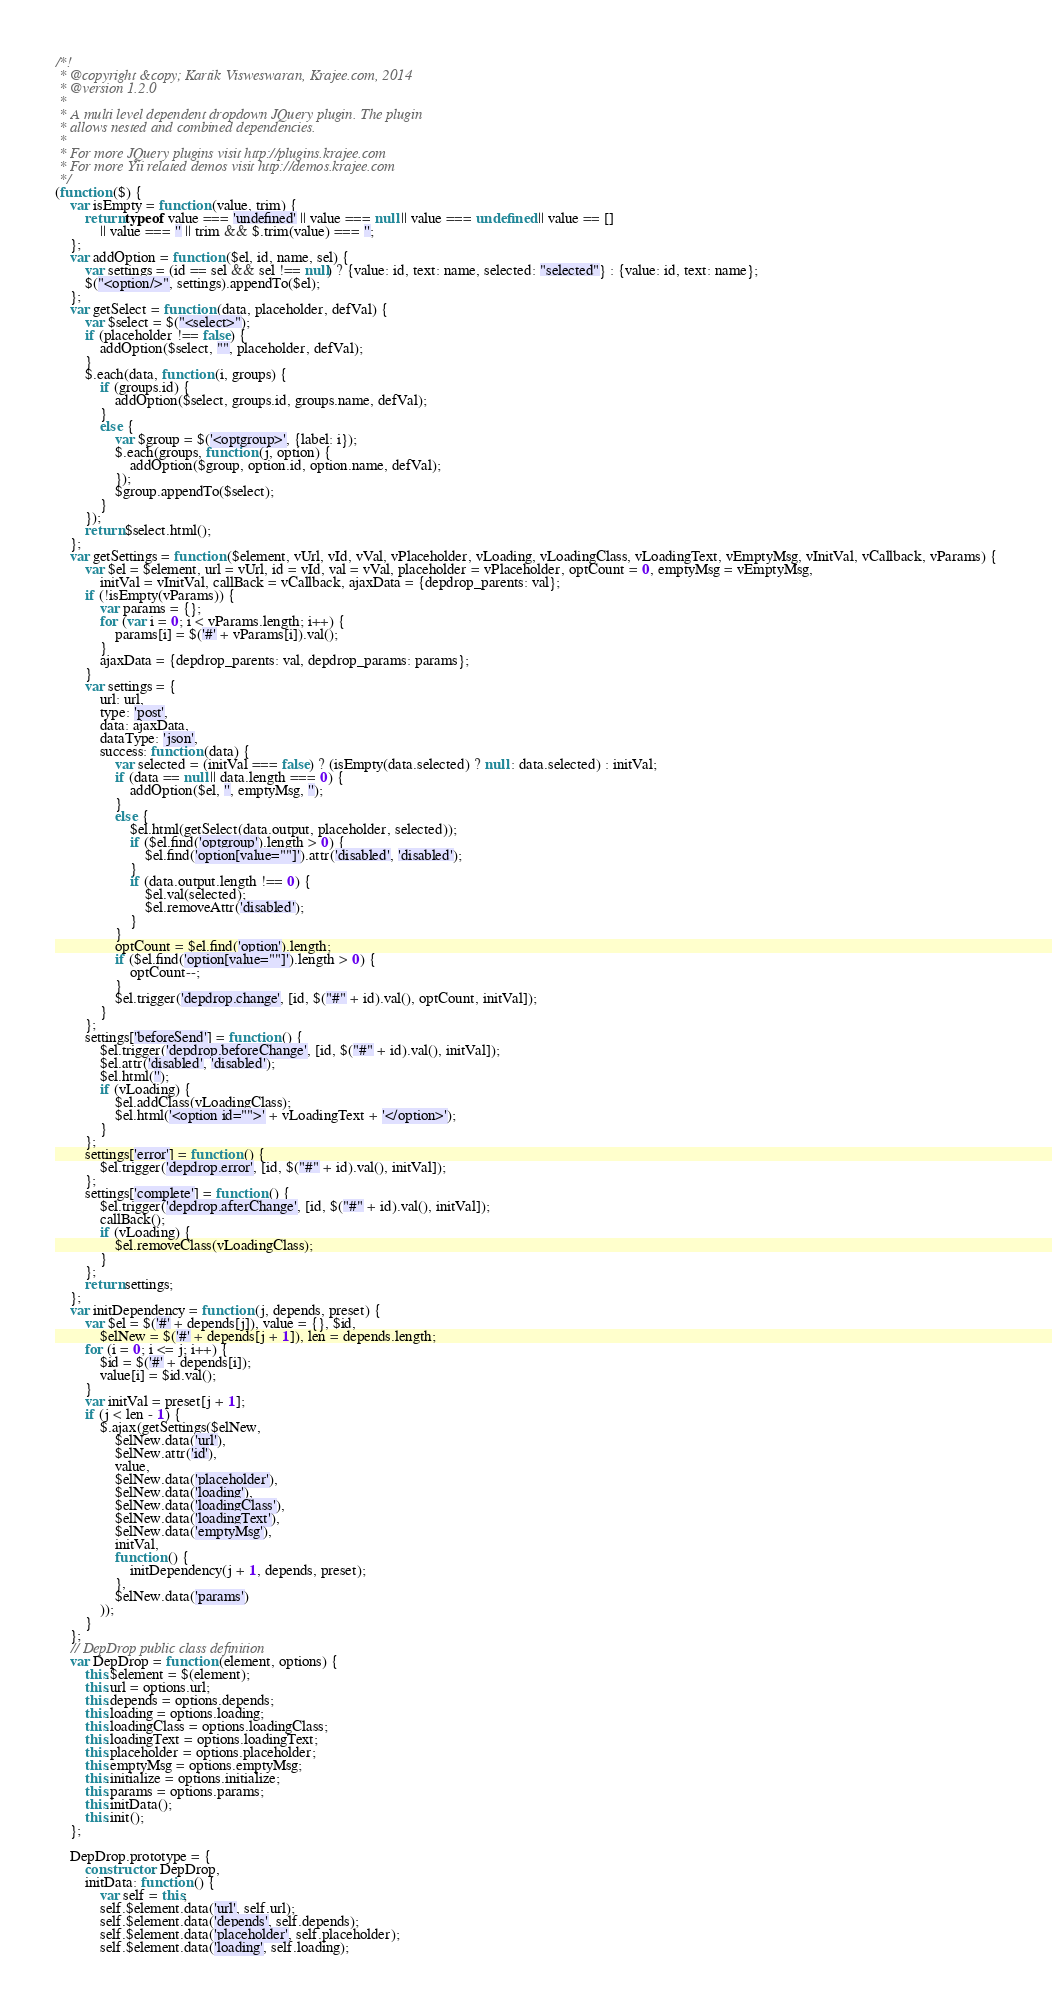Convert code to text. <code><loc_0><loc_0><loc_500><loc_500><_JavaScript_>/*!
 * @copyright &copy; Kartik Visweswaran, Krajee.com, 2014
 * @version 1.2.0
 *
 * A multi level dependent dropdown JQuery plugin. The plugin
 * allows nested and combined dependencies.
 * 
 * For more JQuery plugins visit http://plugins.krajee.com
 * For more Yii related demos visit http://demos.krajee.com
 */
(function ($) {
    var isEmpty = function (value, trim) {
        return typeof value === 'undefined' || value === null || value === undefined || value == []
            || value === '' || trim && $.trim(value) === '';
    };
    var addOption = function ($el, id, name, sel) {
        var settings = (id == sel && sel !== null) ? {value: id, text: name, selected: "selected"} : {value: id, text: name};
        $("<option/>", settings).appendTo($el);
    };
    var getSelect = function (data, placeholder, defVal) {
        var $select = $("<select>");
        if (placeholder !== false) {
            addOption($select, "", placeholder, defVal);
        }
        $.each(data, function (i, groups) {
            if (groups.id) {
                addOption($select, groups.id, groups.name, defVal);
            }
            else {
                var $group = $('<optgroup>', {label: i});
                $.each(groups, function (j, option) {
                    addOption($group, option.id, option.name, defVal);
                });
                $group.appendTo($select);
            }
        });
        return $select.html();
    };
    var getSettings = function ($element, vUrl, vId, vVal, vPlaceholder, vLoading, vLoadingClass, vLoadingText, vEmptyMsg, vInitVal, vCallback, vParams) {
        var $el = $element, url = vUrl, id = vId, val = vVal, placeholder = vPlaceholder, optCount = 0, emptyMsg = vEmptyMsg,
            initVal = vInitVal, callBack = vCallback, ajaxData = {depdrop_parents: val};
        if (!isEmpty(vParams)) {
            var params = {};
            for (var i = 0; i < vParams.length; i++) {
                params[i] = $('#' + vParams[i]).val();
            }
            ajaxData = {depdrop_parents: val, depdrop_params: params};
        }
        var settings = {
            url: url,
            type: 'post',
            data: ajaxData,
            dataType: 'json',
            success: function (data) {
                var selected = (initVal === false) ? (isEmpty(data.selected) ? null : data.selected) : initVal;
                if (data == null || data.length === 0) {
                    addOption($el, '', emptyMsg, '');
                }
                else {
                    $el.html(getSelect(data.output, placeholder, selected));
                    if ($el.find('optgroup').length > 0) {
                        $el.find('option[value=""]').attr('disabled', 'disabled');
                    }
                    if (data.output.length !== 0) {
                        $el.val(selected);
                        $el.removeAttr('disabled');
                    }
                }
                optCount = $el.find('option').length;
                if ($el.find('option[value=""]').length > 0) {
                    optCount--;
                }
                $el.trigger('depdrop.change', [id, $("#" + id).val(), optCount, initVal]);
            }
        };
        settings['beforeSend'] = function () {
            $el.trigger('depdrop.beforeChange', [id, $("#" + id).val(), initVal]);
            $el.attr('disabled', 'disabled');
            $el.html('');
            if (vLoading) {
                $el.addClass(vLoadingClass);
                $el.html('<option id="">' + vLoadingText + '</option>');
            }
        };
        settings['error'] = function () {
            $el.trigger('depdrop.error', [id, $("#" + id).val(), initVal]);
        };
        settings['complete'] = function () {
            $el.trigger('depdrop.afterChange', [id, $("#" + id).val(), initVal]);
            callBack();
            if (vLoading) {
                $el.removeClass(vLoadingClass);
            }
        };
        return settings;
    };
    var initDependency = function (j, depends, preset) {
        var $el = $('#' + depends[j]), value = {}, $id,
            $elNew = $('#' + depends[j + 1]), len = depends.length;
        for (i = 0; i <= j; i++) {
            $id = $('#' + depends[i]);
            value[i] = $id.val();
        }
        var initVal = preset[j + 1];
        if (j < len - 1) {
            $.ajax(getSettings($elNew,
                $elNew.data('url'),
                $elNew.attr('id'),
                value,
                $elNew.data('placeholder'),
                $elNew.data('loading'),
                $elNew.data('loadingClass'),
                $elNew.data('loadingText'),
                $elNew.data('emptyMsg'),
                initVal,
                function () {
                    initDependency(j + 1, depends, preset);
                },
                $elNew.data('params')
            ));
        }
    };
    // DepDrop public class definition
    var DepDrop = function (element, options) {
        this.$element = $(element);
        this.url = options.url;
        this.depends = options.depends;
        this.loading = options.loading;
        this.loadingClass = options.loadingClass;
        this.loadingText = options.loadingText;
        this.placeholder = options.placeholder;
        this.emptyMsg = options.emptyMsg;
        this.initialize = options.initialize;
        this.params = options.params;
        this.initData();
        this.init();
    };

    DepDrop.prototype = {
        constructor: DepDrop,
        initData: function () {
            var self = this;
            self.$element.data('url', self.url);
            self.$element.data('depends', self.depends);
            self.$element.data('placeholder', self.placeholder);
            self.$element.data('loading', self.loading);</code> 